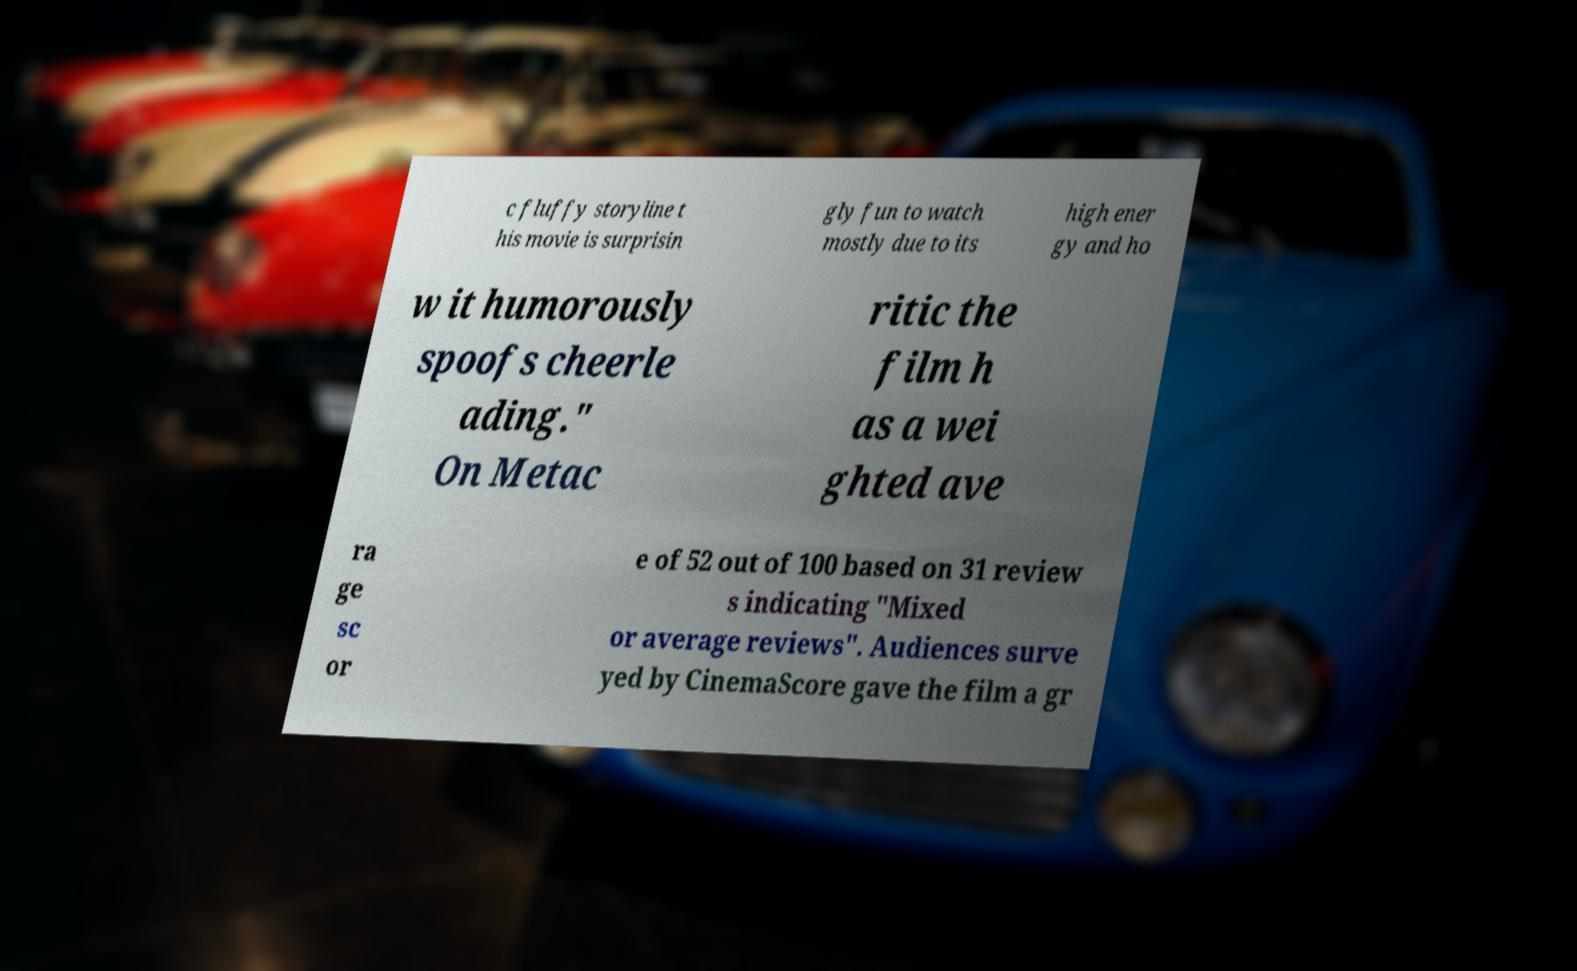I need the written content from this picture converted into text. Can you do that? c fluffy storyline t his movie is surprisin gly fun to watch mostly due to its high ener gy and ho w it humorously spoofs cheerle ading." On Metac ritic the film h as a wei ghted ave ra ge sc or e of 52 out of 100 based on 31 review s indicating "Mixed or average reviews". Audiences surve yed by CinemaScore gave the film a gr 